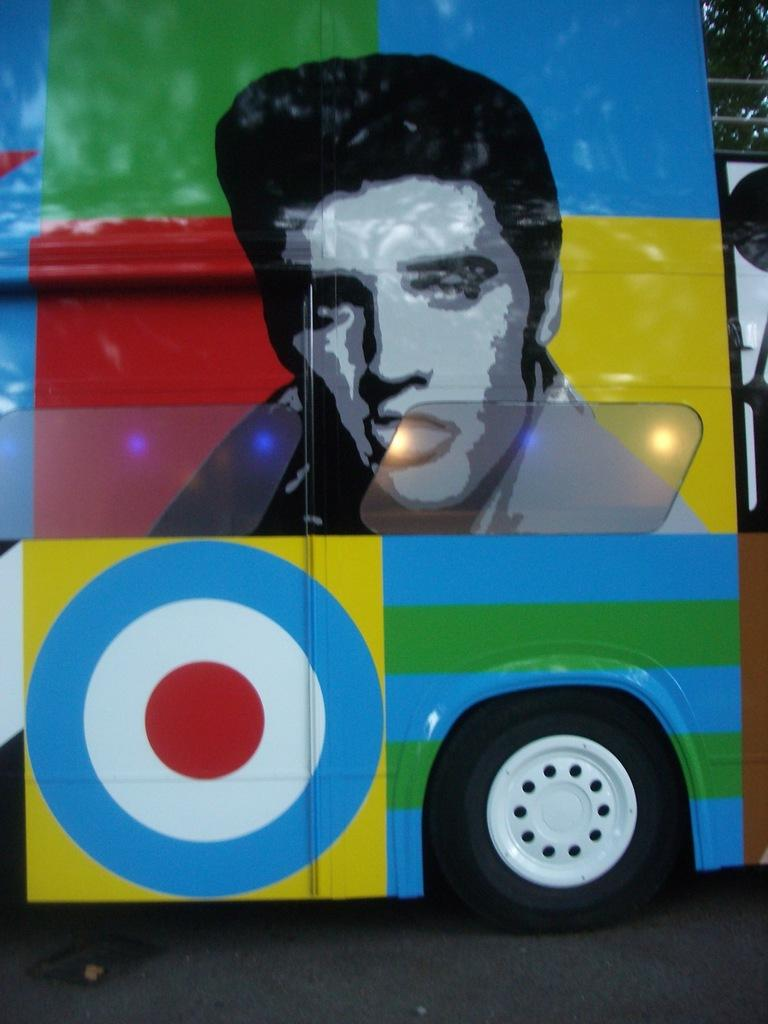What is the main subject of the image? There is a bus in the center of the image. Can you describe any additional details about the bus? There is graffiti on the bus. What type of error can be seen in the image? There is no error present in the image; it features a bus with graffiti. 